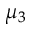Convert formula to latex. <formula><loc_0><loc_0><loc_500><loc_500>\mu _ { 3 }</formula> 